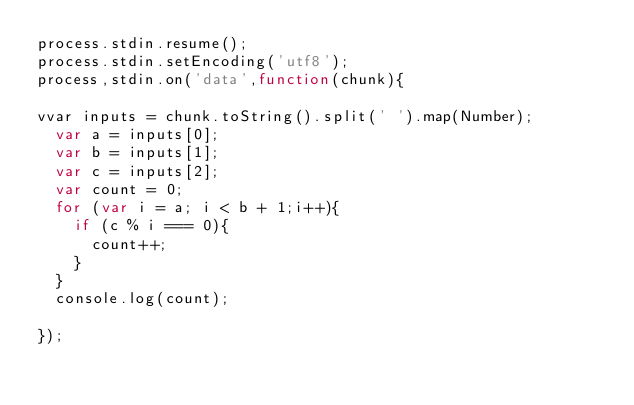Convert code to text. <code><loc_0><loc_0><loc_500><loc_500><_JavaScript_>process.stdin.resume();
process.stdin.setEncoding('utf8');
process,stdin.on('data',function(chunk){

vvar inputs = chunk.toString().split(' ').map(Number);
  var a = inputs[0];
  var b = inputs[1];
  var c = inputs[2];
  var count = 0;
  for (var i = a; i < b + 1;i++){
    if (c % i === 0){
      count++;
    }
  }
  console.log(count);

});</code> 